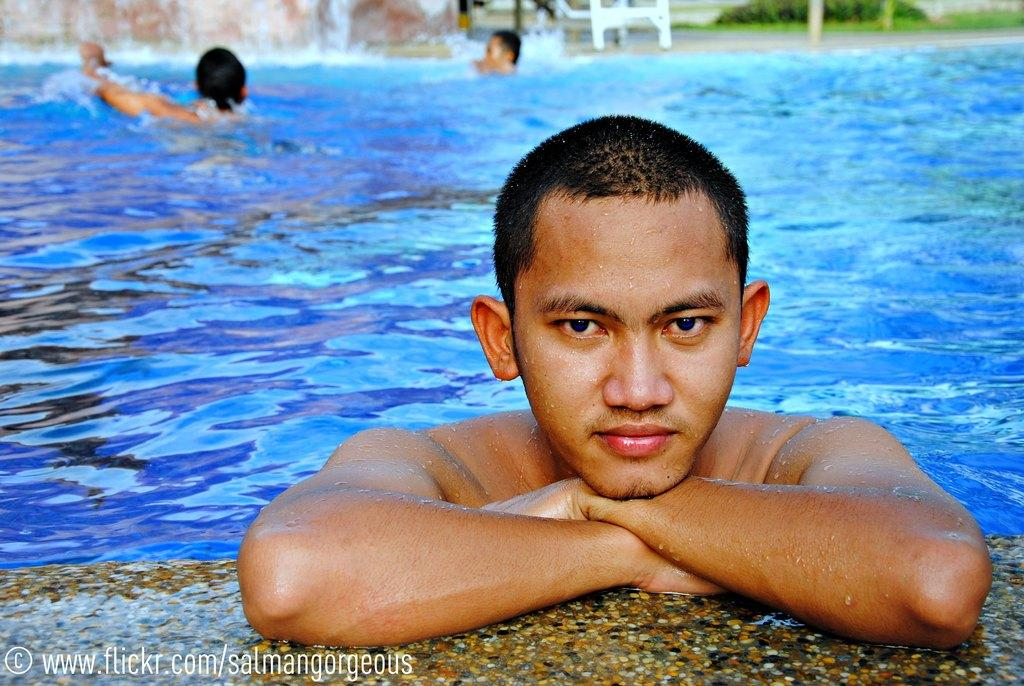What is the primary element in the image? There is water in the image. What are the people in the image doing? The people are in the water. How would you describe the quality of the image's background? The image is blurry in the background. Can you identify any additional features in the image? There is a watermark in the image. What type of quicksand can be seen in the image? There is no quicksand present in the image; it features water with people in it. How many oranges are visible in the image? There are no oranges present in the image. 